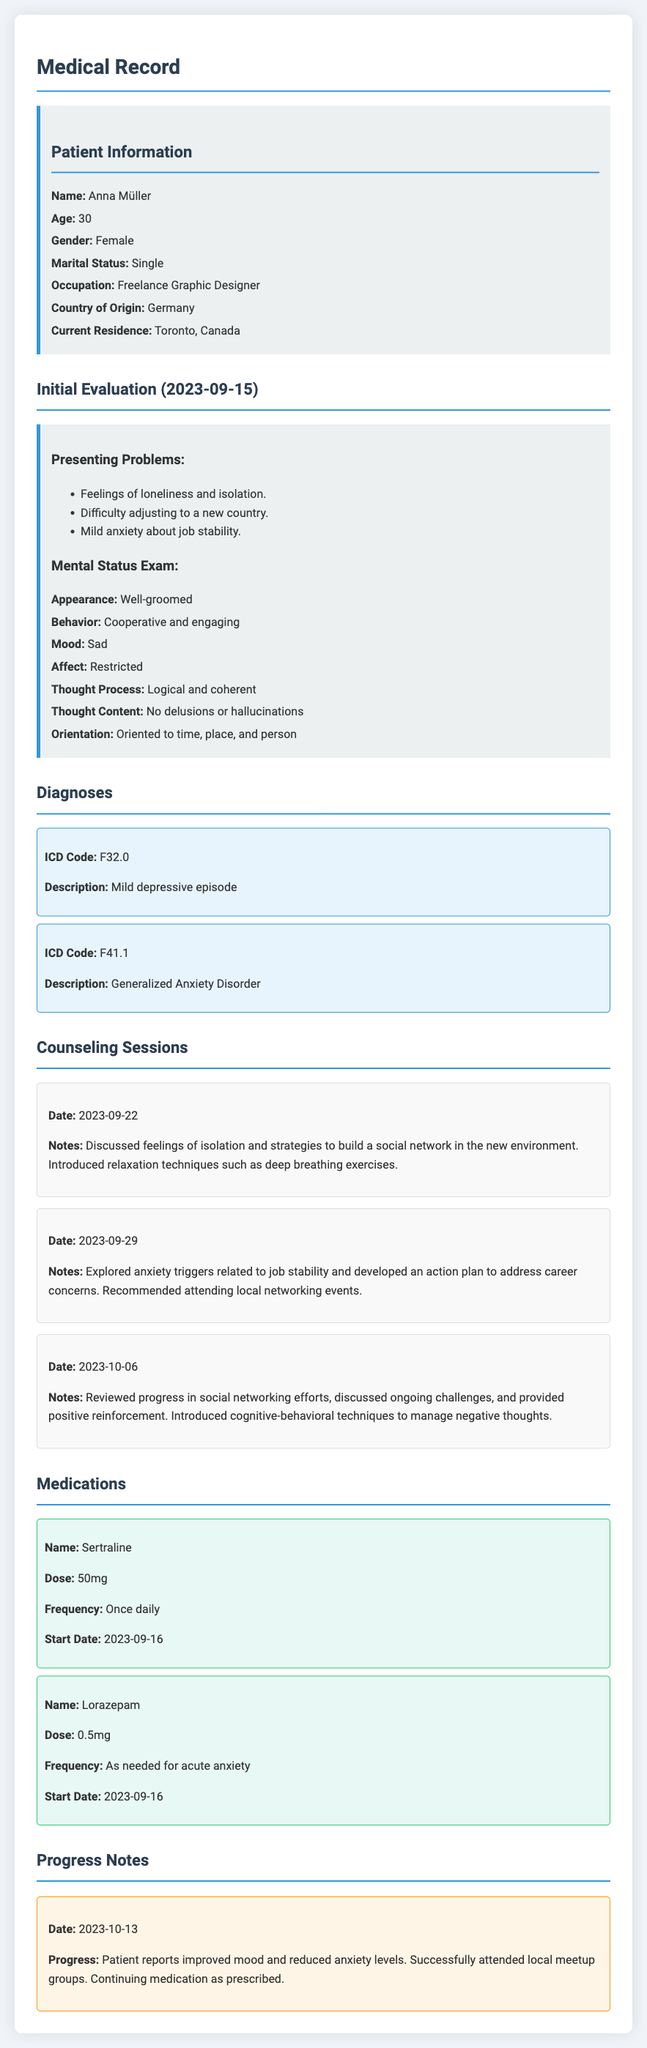what is the patient's name? The patient's name is listed in the document under Patient Information.
Answer: Anna Müller what is the ICD code for Generalized Anxiety Disorder? The ICD code for Generalized Anxiety Disorder is mentioned in the Diagnoses section of the document.
Answer: F41.1 how many counseling sessions are documented? The document outlines three counseling sessions, as specified in the Counseling Sessions section.
Answer: Three what date did the initial evaluation take place? The date of the initial evaluation is mentioned in the Initial Evaluation section of the document.
Answer: 2023-09-15 what medication is prescribed for acute anxiety? The medication prescribed for acute anxiety is listed in the Medications section of the document.
Answer: Lorazepam what is the patient's current residence? The patient's current residence is specified in the Patient Information section.
Answer: Toronto, Canada what strategy was discussed on 2023-09-22? The strategy discussed on 2023-09-22 is noted in the Counseling Sessions section of the document.
Answer: Building a social network what was the patient's mood during the Mental Status Exam? The patient's mood is described in the Mental Status Exam section of the document.
Answer: Sad what is the frequency of the medication Sertraline? The frequency of the medication Sertraline is stated in the Medications section.
Answer: Once daily 